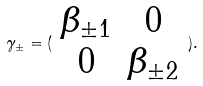Convert formula to latex. <formula><loc_0><loc_0><loc_500><loc_500>\gamma _ { \pm } = ( \begin{array} { c c } \beta _ { \pm 1 } & 0 \\ 0 & \beta _ { \pm 2 } \end{array} ) .</formula> 